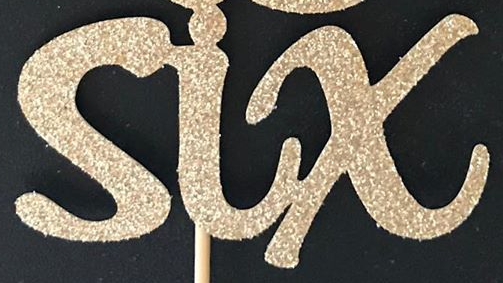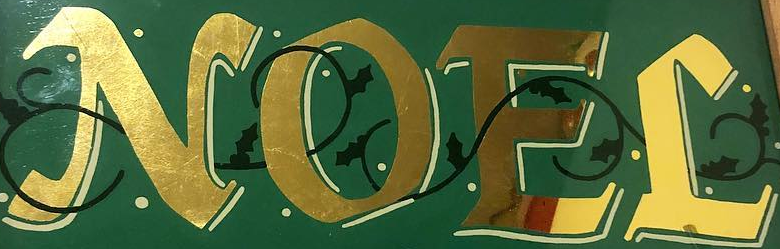Read the text content from these images in order, separated by a semicolon. six; NOEL 